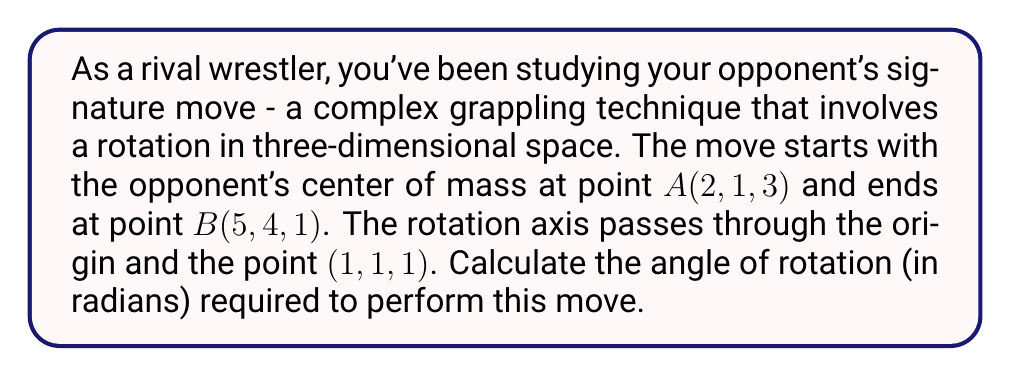Provide a solution to this math problem. To solve this problem, we'll follow these steps:

1) First, we need to find the vector representing the rotation axis. Let's call it $\vec{v}$:
   $$\vec{v} = (1, 1, 1) - (0, 0, 0) = (1, 1, 1)$$

2) Now, we need to find the vectors from the rotation axis to points A and B. Let's call them $\vec{a}$ and $\vec{b}$ respectively:
   $$\vec{a} = (2, 1, 3) - (0, 0, 0) = (2, 1, 3)$$
   $$\vec{b} = (5, 4, 1) - (0, 0, 0) = (5, 4, 1)$$

3) We need to project these vectors onto a plane perpendicular to the rotation axis. We can do this by subtracting their projections onto $\vec{v}$ from themselves:
   $$\vec{a}_{\perp} = \vec{a} - \frac{\vec{a} \cdot \vec{v}}{\|\vec{v}\|^2}\vec{v}$$
   $$\vec{b}_{\perp} = \vec{b} - \frac{\vec{b} \cdot \vec{v}}{\|\vec{v}\|^2}\vec{v}$$

4) Calculate $\vec{a} \cdot \vec{v}$ and $\vec{b} \cdot \vec{v}$:
   $$\vec{a} \cdot \vec{v} = 2(1) + 1(1) + 3(1) = 6$$
   $$\vec{b} \cdot \vec{v} = 5(1) + 4(1) + 1(1) = 10$$

5) Calculate $\|\vec{v}\|^2$:
   $$\|\vec{v}\|^2 = 1^2 + 1^2 + 1^2 = 3$$

6) Now we can calculate $\vec{a}_{\perp}$ and $\vec{b}_{\perp}$:
   $$\vec{a}_{\perp} = (2, 1, 3) - \frac{6}{3}(1, 1, 1) = (0, -1, 1)$$
   $$\vec{b}_{\perp} = (5, 4, 1) - \frac{10}{3}(1, 1, 1) = (\frac{5}{3}, \frac{2}{3}, -\frac{7}{3})$$

7) The angle between these vectors is the rotation angle. We can find it using the dot product formula:
   $$\cos \theta = \frac{\vec{a}_{\perp} \cdot \vec{b}_{\perp}}{\|\vec{a}_{\perp}\| \|\vec{b}_{\perp}\|}$$

8) Calculate the dot product and magnitudes:
   $$\vec{a}_{\perp} \cdot \vec{b}_{\perp} = 0(\frac{5}{3}) + (-1)(\frac{2}{3}) + 1(-\frac{7}{3}) = -3$$
   $$\|\vec{a}_{\perp}\| = \sqrt{0^2 + (-1)^2 + 1^2} = \sqrt{2}$$
   $$\|\vec{b}_{\perp}\| = \sqrt{(\frac{5}{3})^2 + (\frac{2}{3})^2 + (-\frac{7}{3})^2} = 3$$

9) Substitute into the formula:
   $$\cos \theta = \frac{-3}{\sqrt{2} \cdot 3} = -\frac{1}{\sqrt{2}}$$

10) Finally, take the arccos to find $\theta$:
    $$\theta = \arccos(-\frac{1}{\sqrt{2}})$$
Answer: The angle of rotation is $\arccos(-\frac{1}{\sqrt{2}})$ radians, which is approximately 2.356 radians or 135 degrees. 